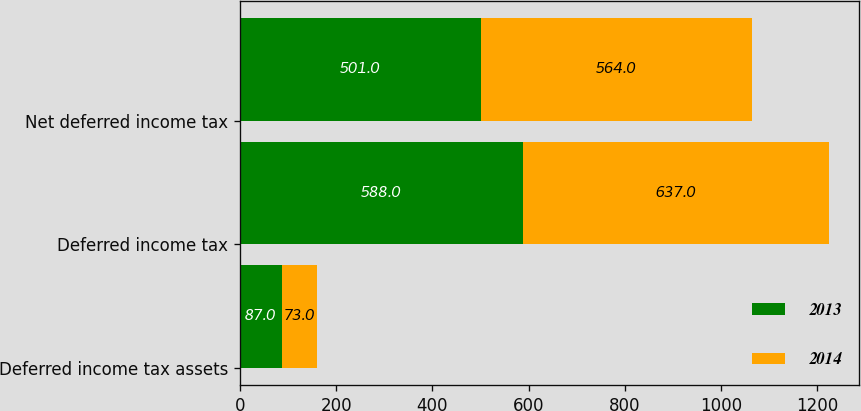<chart> <loc_0><loc_0><loc_500><loc_500><stacked_bar_chart><ecel><fcel>Deferred income tax assets<fcel>Deferred income tax<fcel>Net deferred income tax<nl><fcel>2013<fcel>87<fcel>588<fcel>501<nl><fcel>2014<fcel>73<fcel>637<fcel>564<nl></chart> 